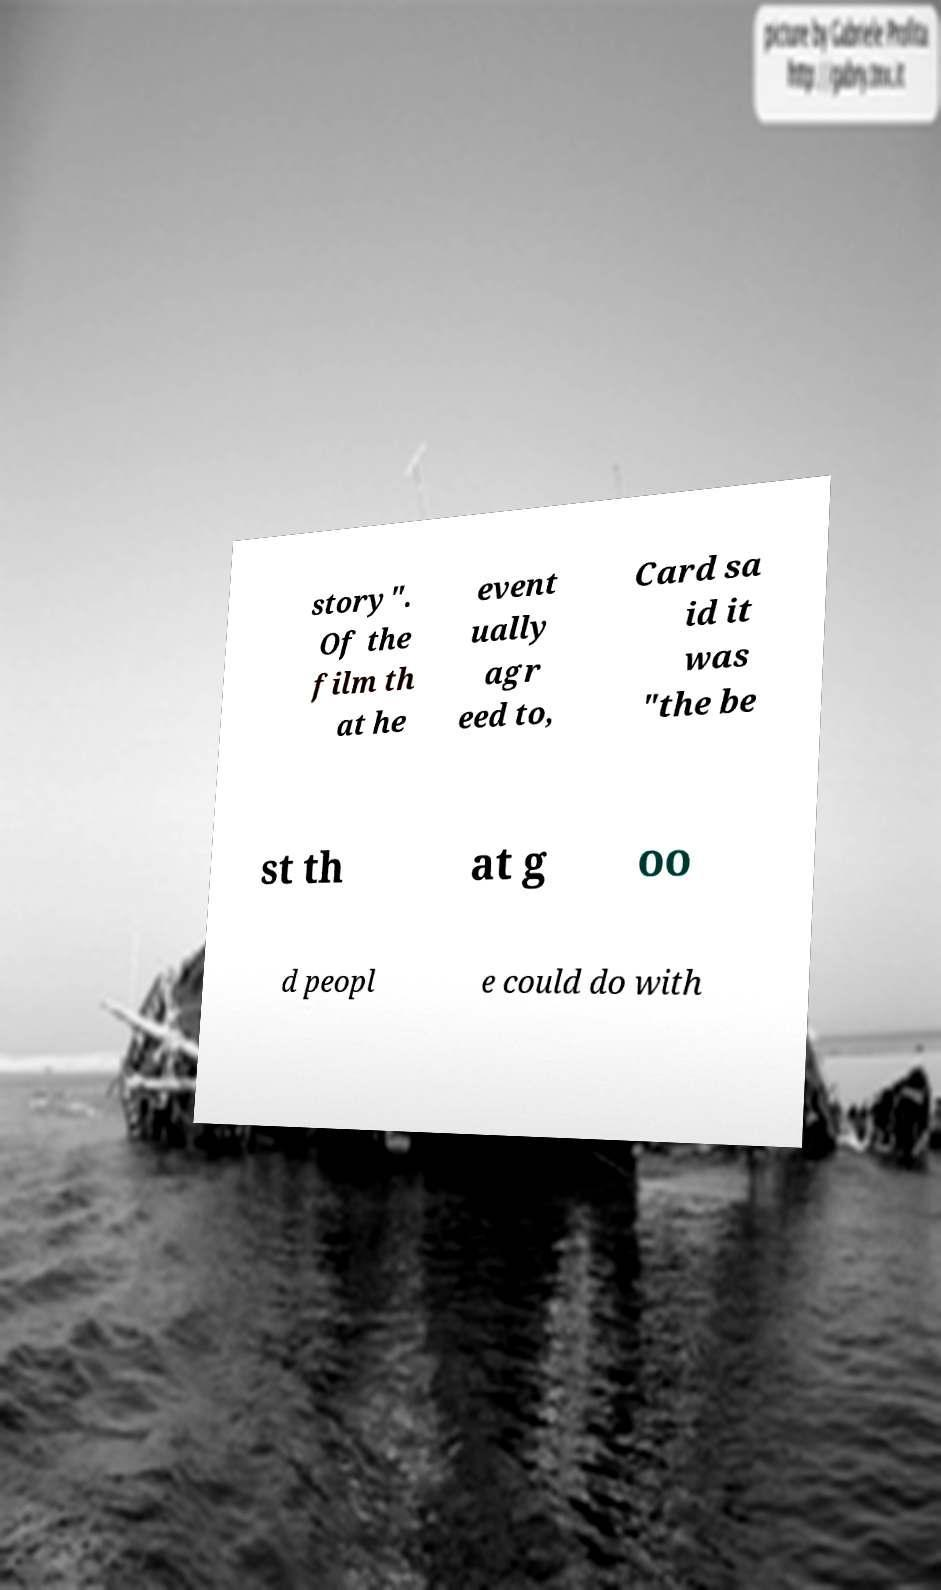Please read and relay the text visible in this image. What does it say? story". Of the film th at he event ually agr eed to, Card sa id it was "the be st th at g oo d peopl e could do with 